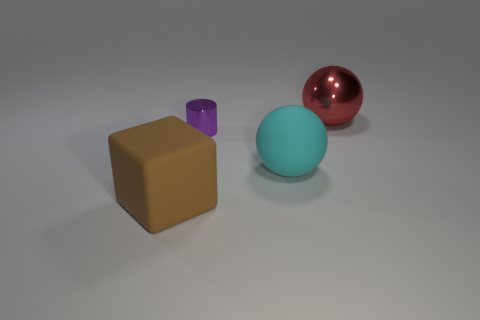Add 4 cyan rubber objects. How many objects exist? 8 Subtract all blocks. How many objects are left? 3 Add 2 large metallic balls. How many large metallic balls exist? 3 Subtract 0 green spheres. How many objects are left? 4 Subtract all large spheres. Subtract all small cylinders. How many objects are left? 1 Add 3 large things. How many large things are left? 6 